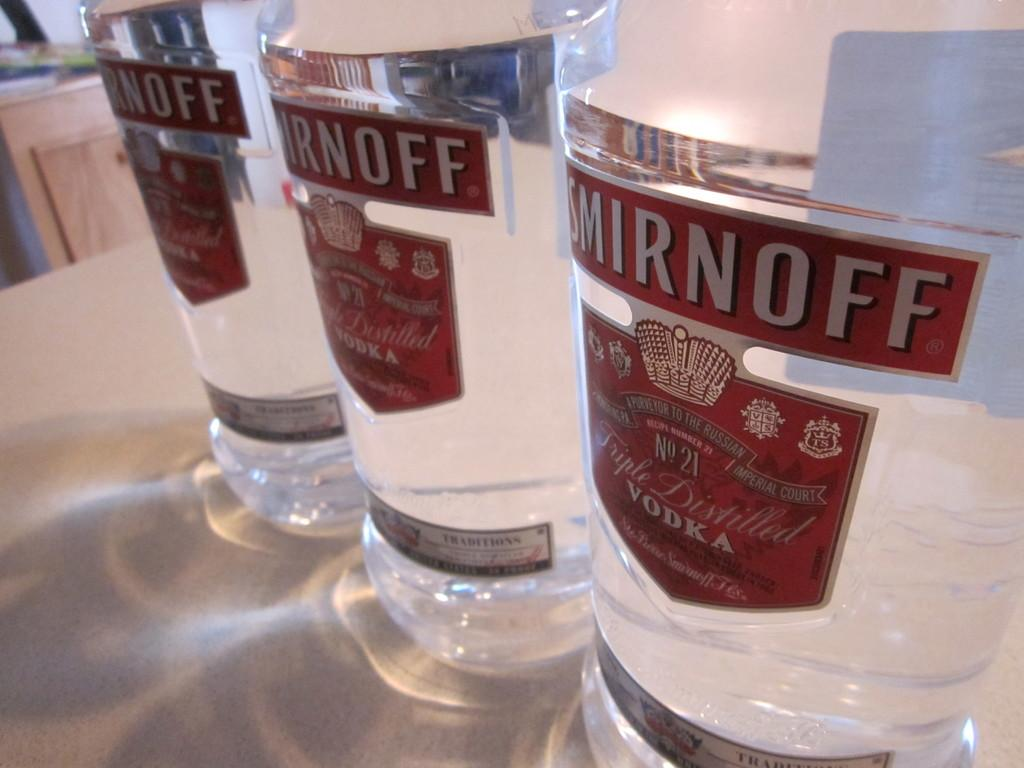<image>
Share a concise interpretation of the image provided. Three bottles of vodka from Smirnoff sitting on a table. 